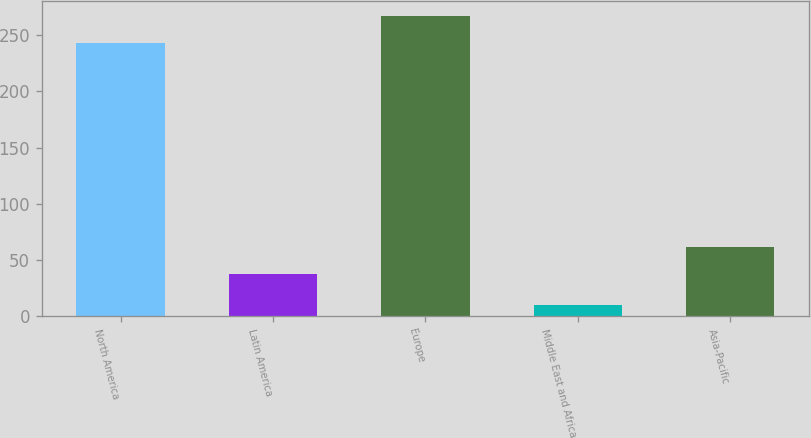Convert chart to OTSL. <chart><loc_0><loc_0><loc_500><loc_500><bar_chart><fcel>North America<fcel>Latin America<fcel>Europe<fcel>Middle East and Africa<fcel>Asia-Pacific<nl><fcel>243.5<fcel>37.3<fcel>267.23<fcel>10.2<fcel>61.03<nl></chart> 